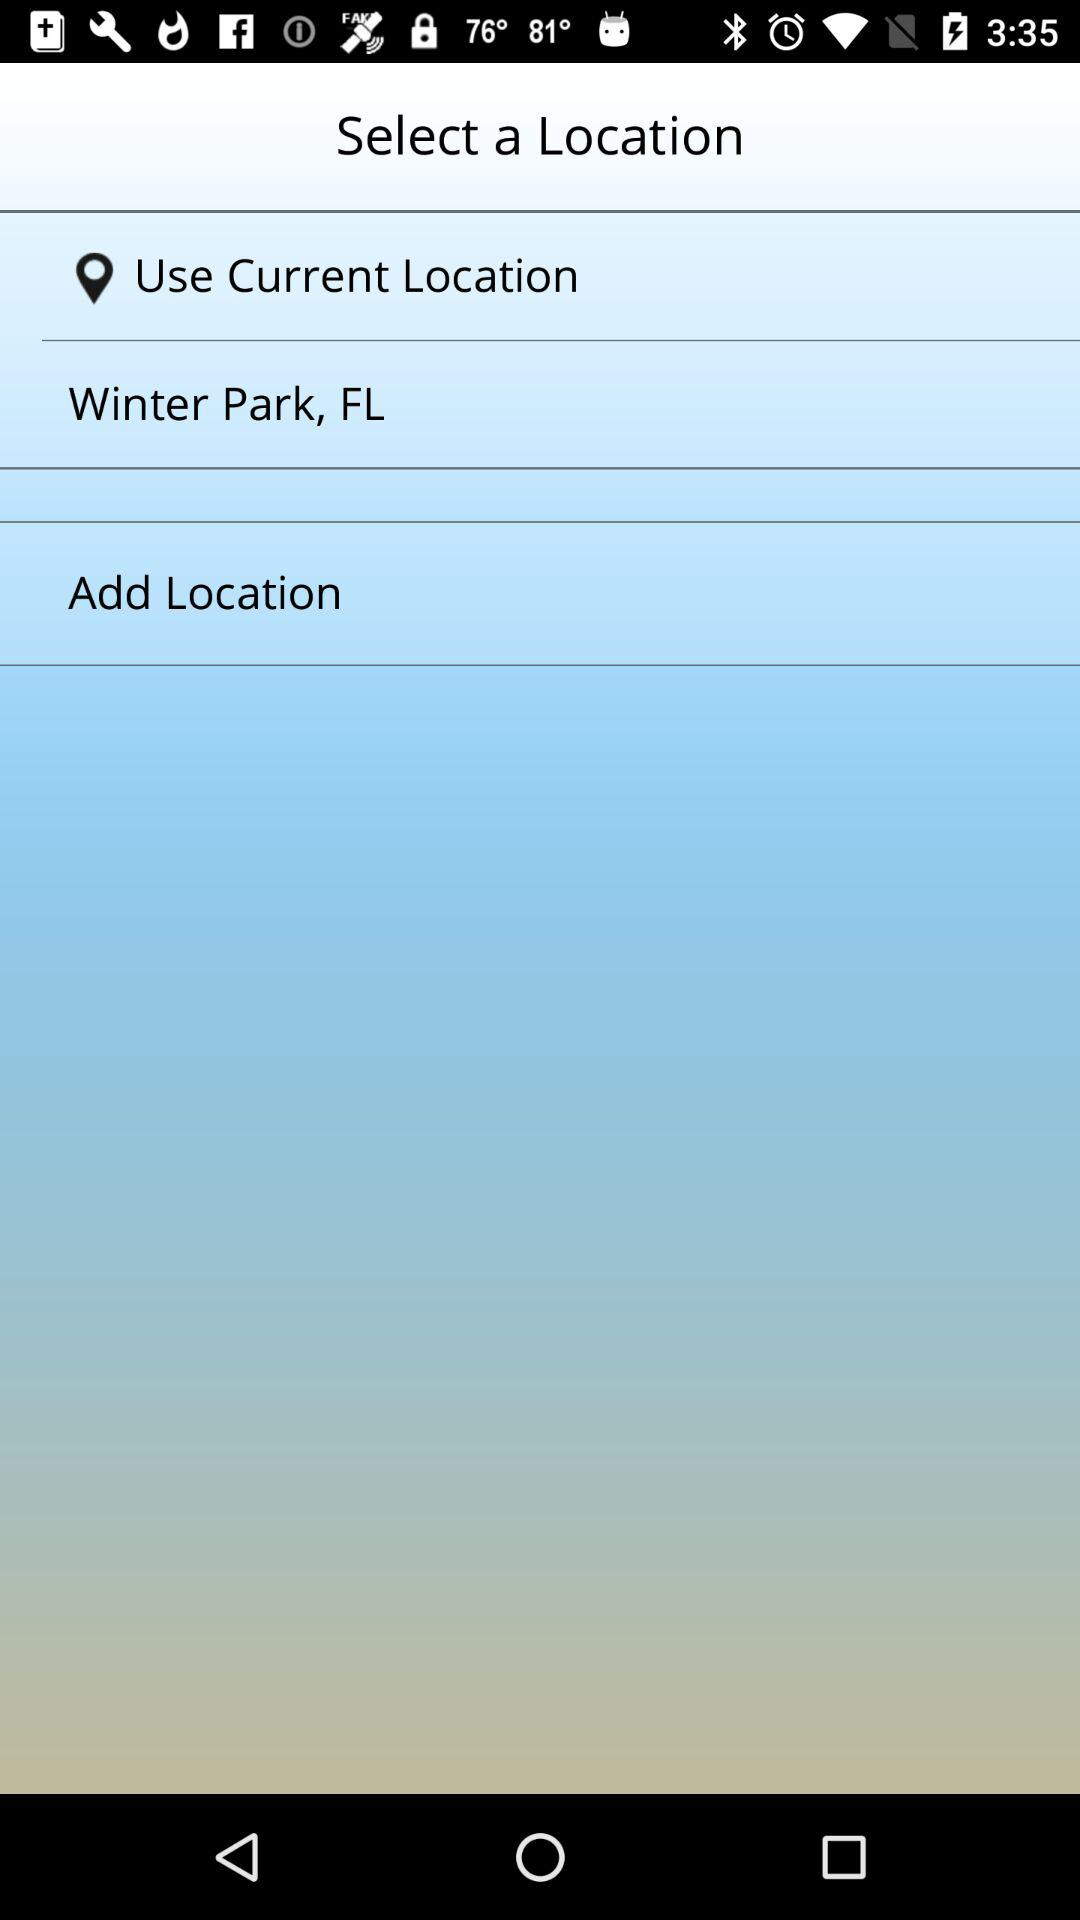What is the current location? The current location is Winter Park, FL. 